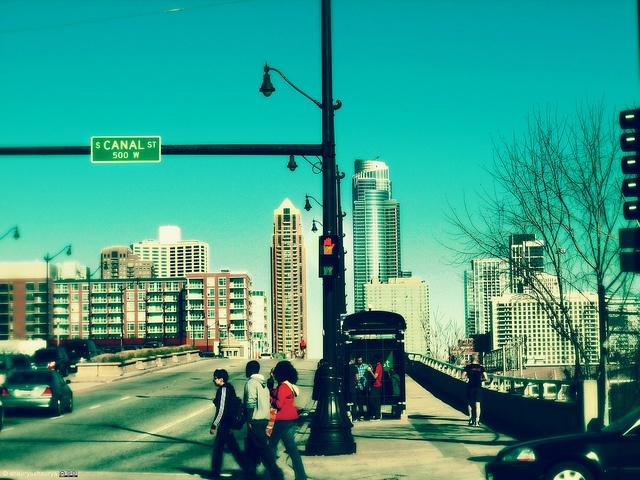Describe the objects in this image and their specific colors. I can see car in teal, black, darkgreen, and khaki tones, traffic light in teal, black, and turquoise tones, people in teal, black, brown, and tan tones, car in teal, navy, khaki, and darkgreen tones, and people in teal, black, khaki, lightgreen, and green tones in this image. 